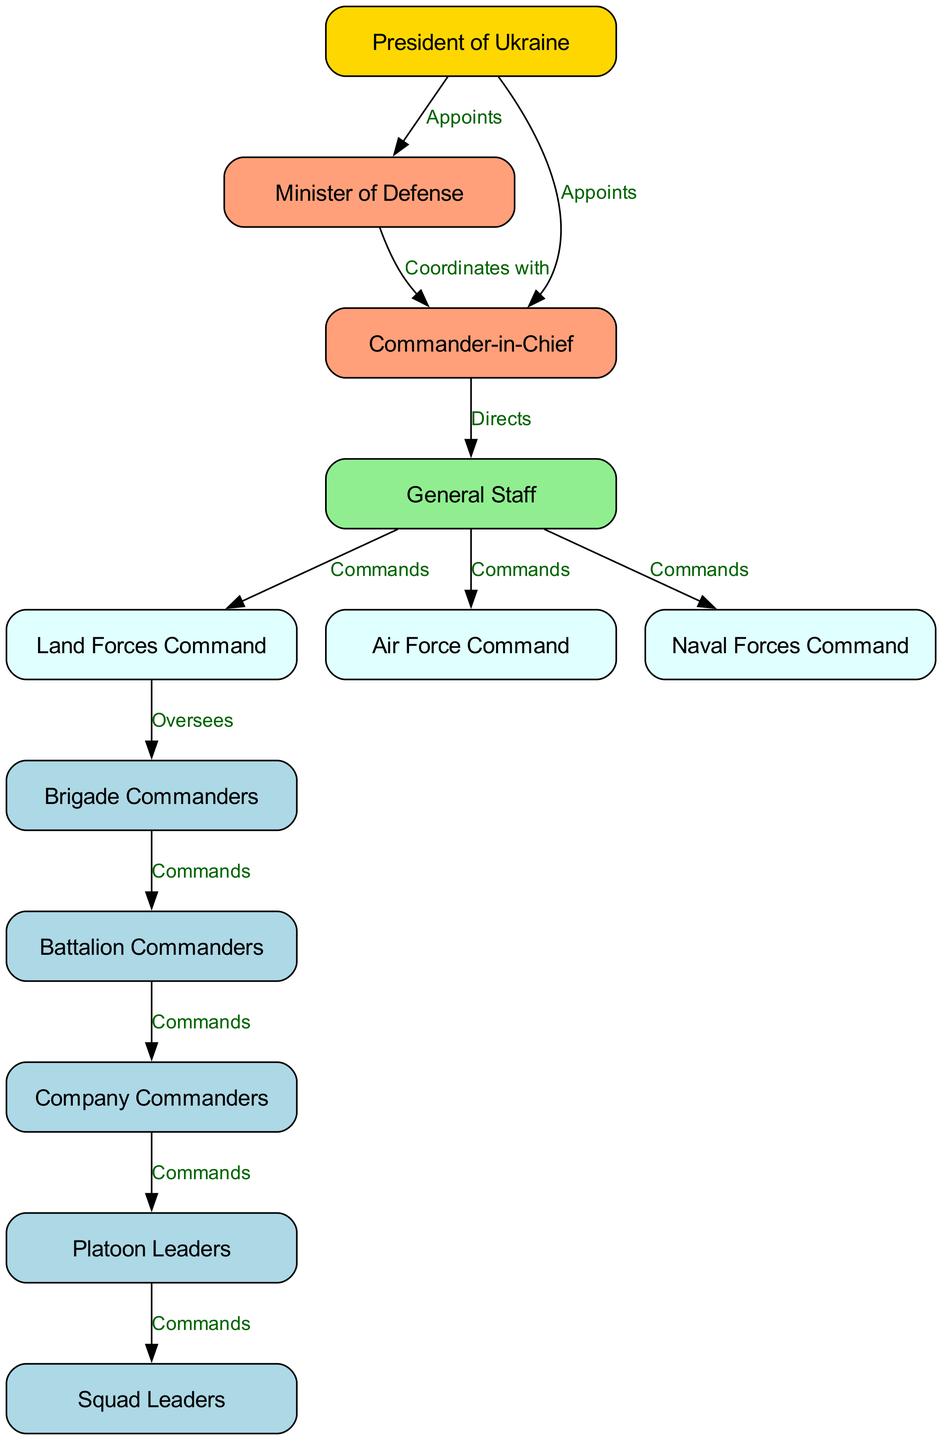What is the highest authority in the chain of command? The diagram shows that the highest authority is represented by the President of Ukraine, at the top of the hierarchy.
Answer: President of Ukraine How many layers are there in the chain of command? The diagram consists of several distinct layers, starting from the President down to the Squad Leaders. Counting these, there are a total of 12 different nodes representing layers.
Answer: 12 Who appoints the Commander-in-Chief? The diagram indicates that the President of Ukraine appoints the Commander-in-Chief, as shown by the edge connecting these two nodes with the label "Appoints."
Answer: President of Ukraine Which nodes directly receive commands from the General Staff? According to the diagram, the Land Forces Command, Air Force Command, and Naval Forces Command receive commands directly from the General Staff, which are indicated by the edges labeled "Commands."
Answer: Land Forces Command, Air Force Command, Naval Forces Command What is the role of Brigade Commanders in the chain of command? The diagram illustrates that Brigade Commanders oversee Battalion Commanders, meaning they are responsible for directing the next level of commanders in the hierarchy.
Answer: Oversees Which two entities coordinate with each other? The diagram shows a direct edge labeled "Coordinates with" between the Minister of Defense and the Commander-in-Chief, indicating their collaborative relationship.
Answer: Minister of Defense, Commander-in-Chief How many commands flow down from Battalion Commanders? The diagram highlights that Battalion Commanders command Company Commanders, meaning there is one command relationship directly descending from Battalion Commanders in this flow.
Answer: 1 What color represents the General Staff in the diagram? The General Staff node is uniquely colored light green in the diagram, distinguishing it from other nodes.
Answer: Light green Which commanders have a direct line of command under Company Commanders? The diagram indicates that Company Commanders directly command Platoon Leaders, showing this relationship via the labeled edge.
Answer: Platoon Leaders What is the relationship between the Land Forces Command and Brigade Commanders? The diagram specifies that the Land Forces Command oversees Brigade Commanders, as shown by the directional edge labeled "Oversees."
Answer: Oversees 